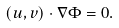<formula> <loc_0><loc_0><loc_500><loc_500>( u , v ) \cdot \nabla \Phi = 0 .</formula> 